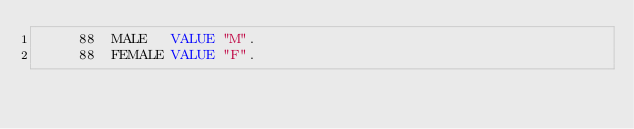Convert code to text. <code><loc_0><loc_0><loc_500><loc_500><_COBOL_>     88  MALE   VALUE "M".
     88  FEMALE VALUE "F".</code> 